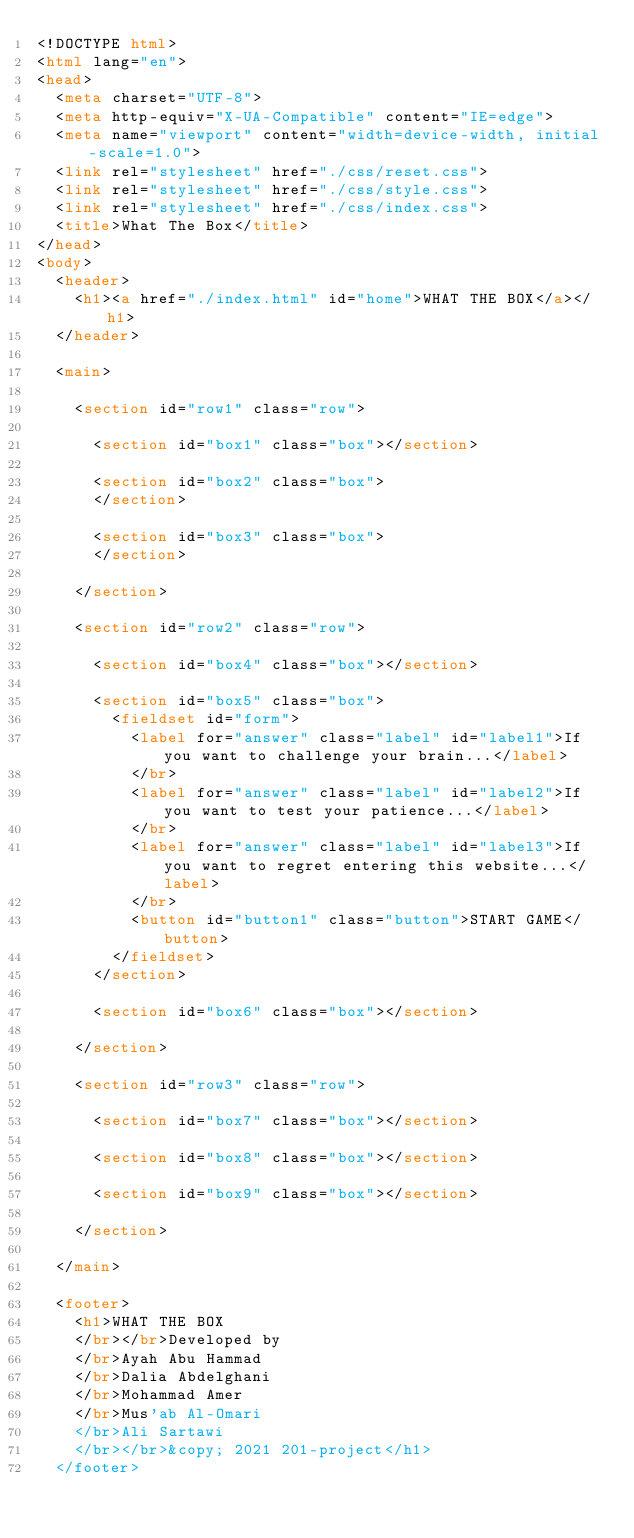<code> <loc_0><loc_0><loc_500><loc_500><_HTML_><!DOCTYPE html>
<html lang="en">
<head>
  <meta charset="UTF-8">
  <meta http-equiv="X-UA-Compatible" content="IE=edge">
  <meta name="viewport" content="width=device-width, initial-scale=1.0">
  <link rel="stylesheet" href="./css/reset.css">
  <link rel="stylesheet" href="./css/style.css">
  <link rel="stylesheet" href="./css/index.css">
  <title>What The Box</title>
</head>
<body>
  <header>
    <h1><a href="./index.html" id="home">WHAT THE BOX</a></h1>
  </header>

  <main>

    <section id="row1" class="row">

      <section id="box1" class="box"></section>

      <section id="box2" class="box">
      </section>

      <section id="box3" class="box">
      </section>

    </section>

    <section id="row2" class="row">

      <section id="box4" class="box"></section>

      <section id="box5" class="box">
        <fieldset id="form">
          <label for="answer" class="label" id="label1">If you want to challenge your brain...</label>
          </br>
          <label for="answer" class="label" id="label2">If you want to test your patience...</label>
          </br>
          <label for="answer" class="label" id="label3">If you want to regret entering this website...</label>
          </br>
          <button id="button1" class="button">START GAME</button>
        </fieldset>
      </section>

      <section id="box6" class="box"></section>

    </section>

    <section id="row3" class="row">

      <section id="box7" class="box"></section>

      <section id="box8" class="box"></section>

      <section id="box9" class="box"></section>

    </section>

  </main>

  <footer>
    <h1>WHAT THE BOX
    </br></br>Developed by
    </br>Ayah Abu Hammad
    </br>Dalia Abdelghani
    </br>Mohammad Amer
    </br>Mus'ab Al-Omari
    </br>Ali Sartawi
    </br></br>&copy; 2021 201-project</h1>
  </footer></code> 